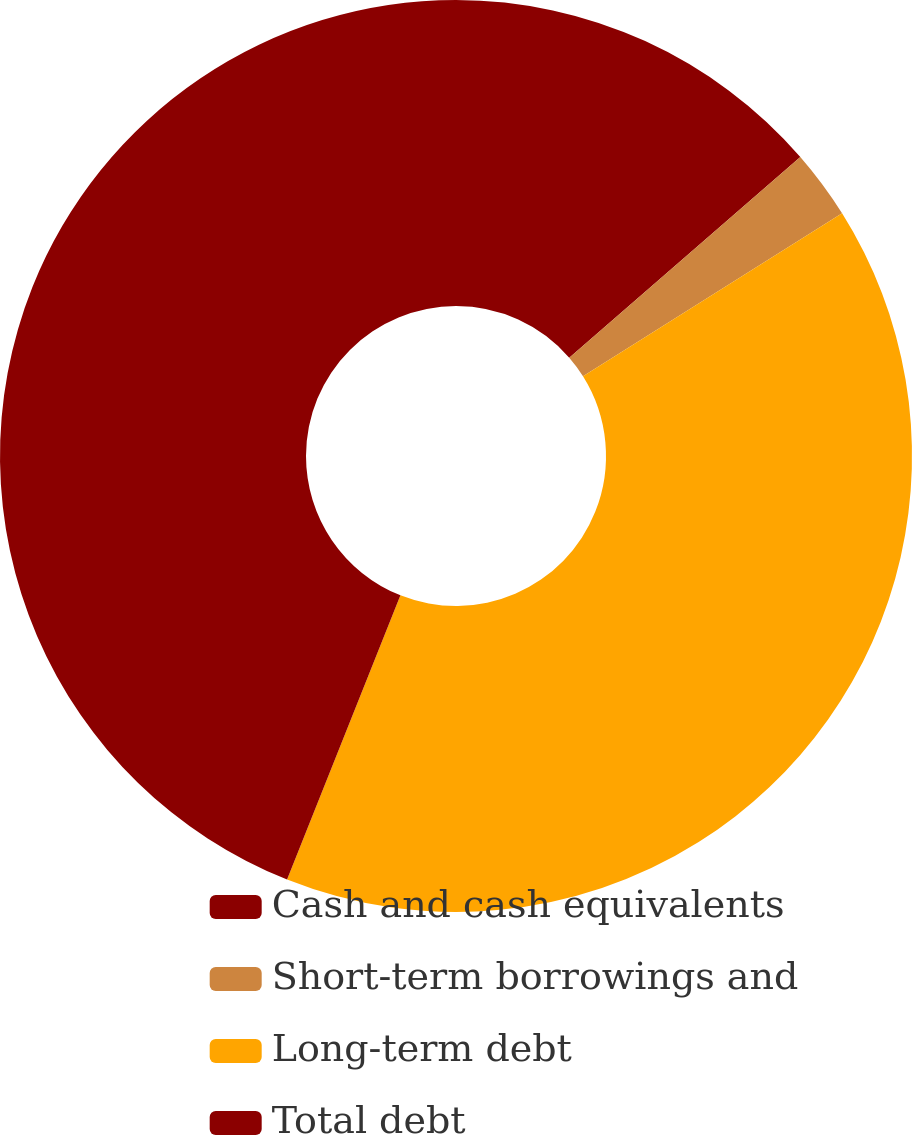Convert chart to OTSL. <chart><loc_0><loc_0><loc_500><loc_500><pie_chart><fcel>Cash and cash equivalents<fcel>Short-term borrowings and<fcel>Long-term debt<fcel>Total debt<nl><fcel>13.62%<fcel>2.45%<fcel>39.97%<fcel>43.96%<nl></chart> 